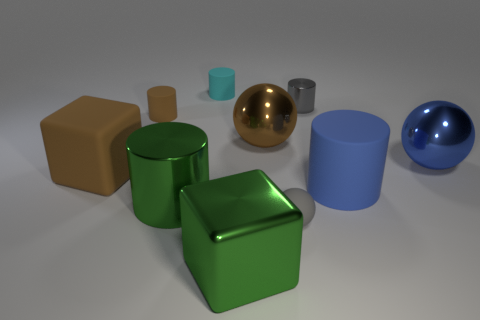Subtract all shiny spheres. How many spheres are left? 1 Subtract all brown cylinders. How many cylinders are left? 4 Subtract all blocks. How many objects are left? 8 Subtract 0 purple balls. How many objects are left? 10 Subtract all purple spheres. Subtract all blue cylinders. How many spheres are left? 3 Subtract all small blue matte objects. Subtract all big green cylinders. How many objects are left? 9 Add 1 cyan cylinders. How many cyan cylinders are left? 2 Add 6 blue cylinders. How many blue cylinders exist? 7 